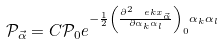Convert formula to latex. <formula><loc_0><loc_0><loc_500><loc_500>\mathcal { P } _ { \vec { \alpha } } = C \mathcal { P } _ { 0 } e ^ { - \frac { 1 } { 2 } \left ( \frac { \partial ^ { 2 } \ e k x _ { \vec { \alpha } } } { \partial \alpha _ { k } \alpha _ { l } } \right ) _ { 0 } \alpha _ { k } \alpha _ { l } }</formula> 